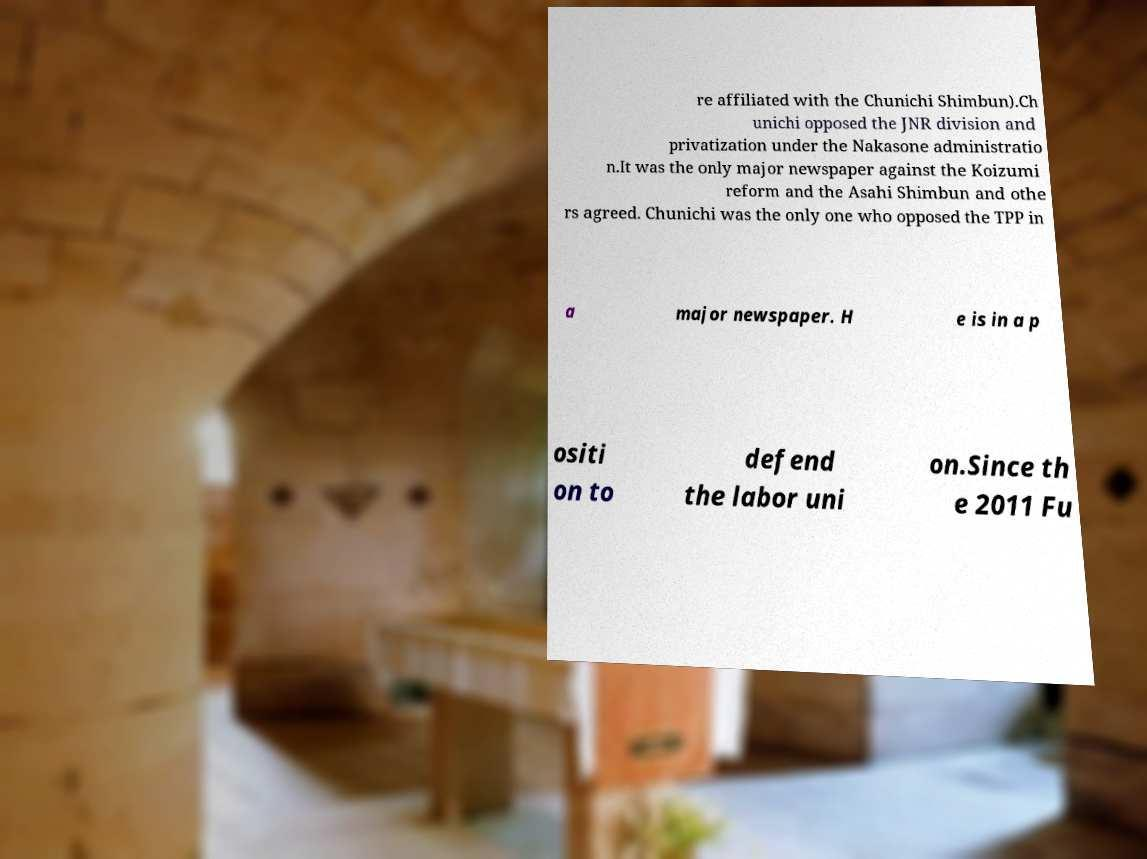There's text embedded in this image that I need extracted. Can you transcribe it verbatim? re affiliated with the Chunichi Shimbun).Ch unichi opposed the JNR division and privatization under the Nakasone administratio n.It was the only major newspaper against the Koizumi reform and the Asahi Shimbun and othe rs agreed. Chunichi was the only one who opposed the TPP in a major newspaper. H e is in a p ositi on to defend the labor uni on.Since th e 2011 Fu 